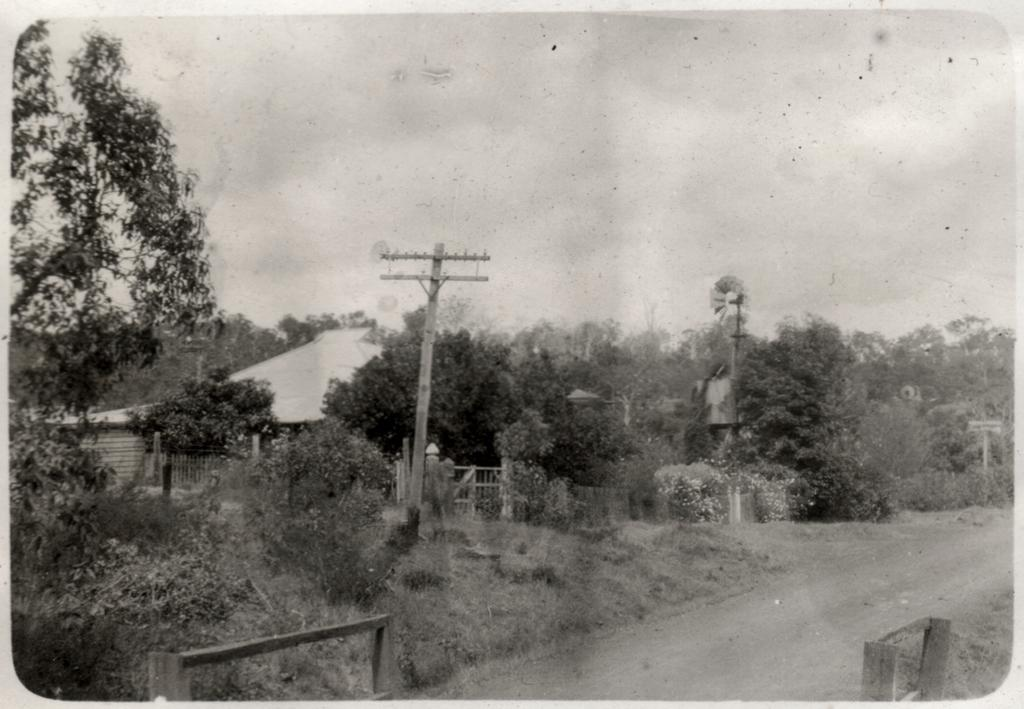What type of vegetation can be seen in the image? There are trees and plants in the image. What structures are present in the image? There is an electric pole, a house, and wooden poles in the image. What part of the natural environment is visible in the image? The sky is visible in the image. Can you tell me how many horses are present in the image? There are no horses present in the image. What type of chain is holding the son in the image? There is no son or chain present in the image. 